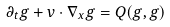<formula> <loc_0><loc_0><loc_500><loc_500>\partial _ { t } g + v \cdot \nabla _ { x } g = Q ( g , g )</formula> 